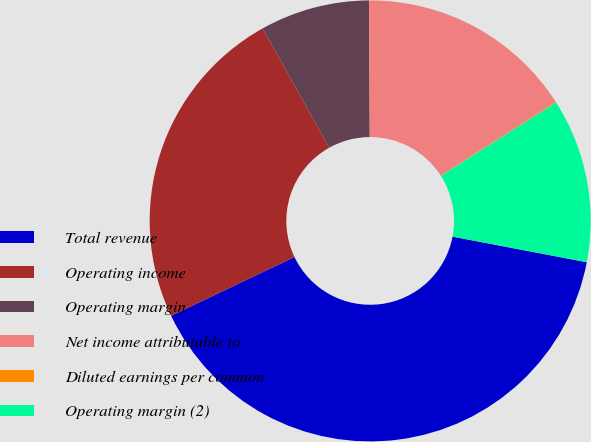Convert chart. <chart><loc_0><loc_0><loc_500><loc_500><pie_chart><fcel>Total revenue<fcel>Operating income<fcel>Operating margin<fcel>Net income attributable to<fcel>Diluted earnings per common<fcel>Operating margin (2)<nl><fcel>39.92%<fcel>23.97%<fcel>8.03%<fcel>16.0%<fcel>0.06%<fcel>12.02%<nl></chart> 